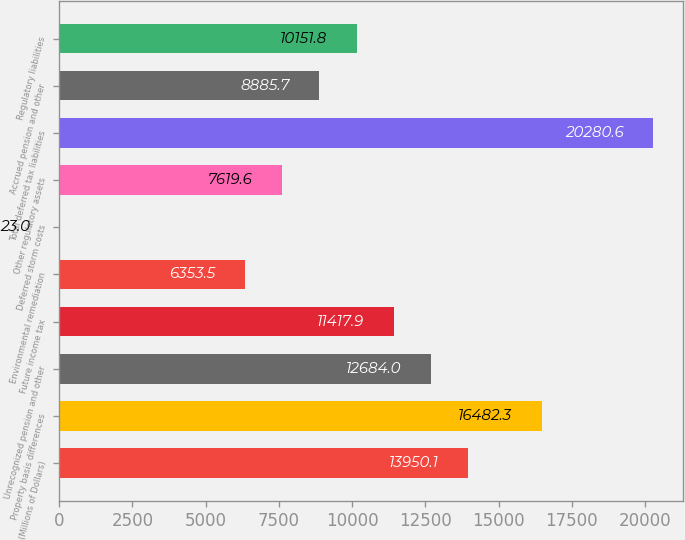Convert chart. <chart><loc_0><loc_0><loc_500><loc_500><bar_chart><fcel>(Millions of Dollars)<fcel>Property basis differences<fcel>Unrecognized pension and other<fcel>Future income tax<fcel>Environmental remediation<fcel>Deferred storm costs<fcel>Other regulatory assets<fcel>Total deferred tax liabilities<fcel>Accrued pension and other<fcel>Regulatory liabilities<nl><fcel>13950.1<fcel>16482.3<fcel>12684<fcel>11417.9<fcel>6353.5<fcel>23<fcel>7619.6<fcel>20280.6<fcel>8885.7<fcel>10151.8<nl></chart> 